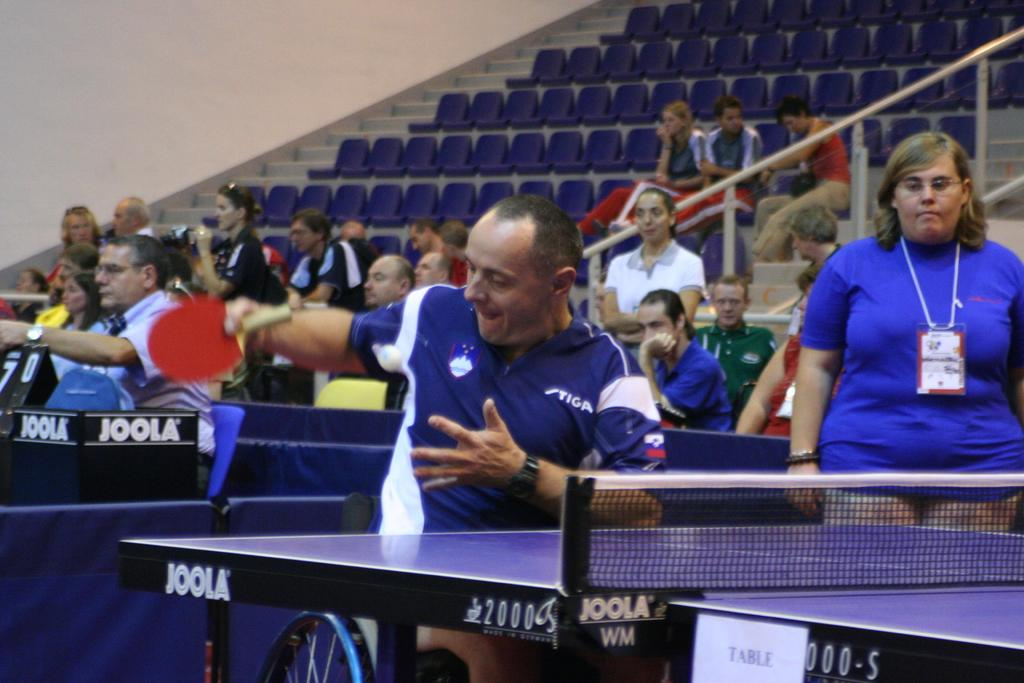What is the person in the image holding? The person is holding a bat in the image. Where is the person standing in relation to other objects? The person is standing in front of a table in the image. What can be seen in the background of the image? There are people sitting on a staircase in the background of the image. What type of bird is perched on the person's shoulder in the image? There is no bird present on the person's shoulder in the image. 